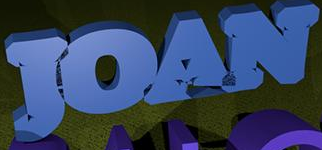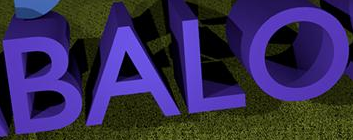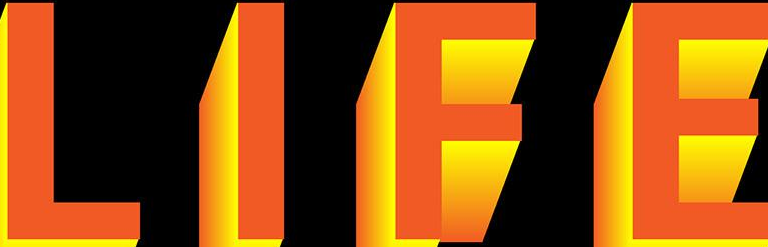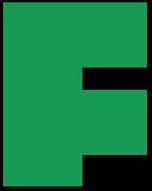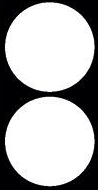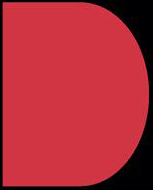Identify the words shown in these images in order, separated by a semicolon. JOAN; BALO; LIFE; F; :; D 